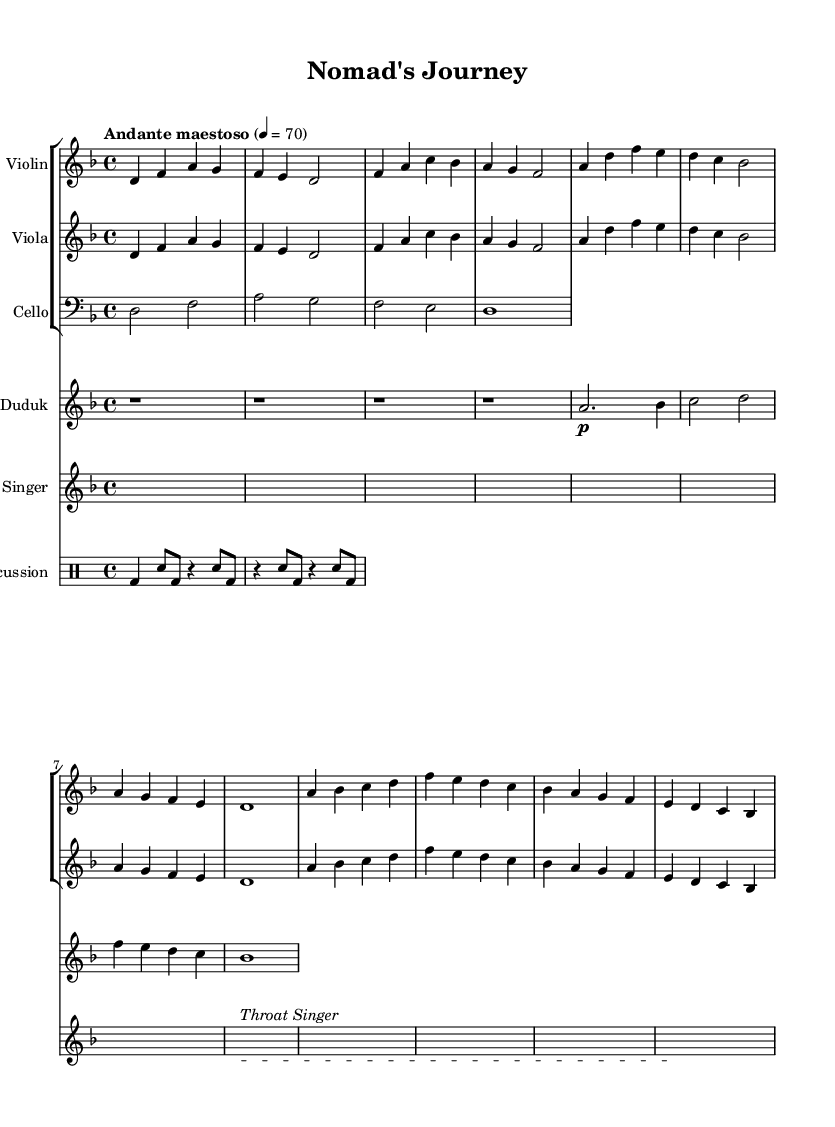What is the key signature of this music? The key signature is D minor, which includes one flat (B flat). It can be identified at the beginning of the staff lines.
Answer: D minor What is the time signature of this music? The time signature is 4/4, indicating four beats per measure, and can be found at the start of the sheet music.
Answer: 4/4 What is the tempo indication for this piece? The tempo is indicated as "Andante maestoso," which suggests a moderately slow and majestic pace, positioned at the top of the sheet music.
Answer: Andante maestoso How many different instrumental parts are notated in the score? There are five different instrumental parts notated: Violin, Viola, Cello, Duduk, and Throat Singer. This can be counted from the staff groups and individual staffs.
Answer: Five In what measure does the Duduk first play a note? The Duduk first plays a note in the second measure after several rest measures, which can be determined by counting the measures from the beginning.
Answer: Measure 2 Which instrument is associated with throat singing, and how is it marked? The Throat Singer is associated with a unique staff named "Throat Singer," and it contains a specific text markup indicating the performance style. This can be seen in the notation that includes the label above the staff.
Answer: Throat Singer What rhythmic pattern do the percussion instruments predominantly follow? The percussion predominantly follows a pattern of bass drums and snare, alternating between quarter notes and eighth notes, as shown in the percussion section.
Answer: Bass and snare 